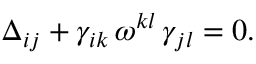Convert formula to latex. <formula><loc_0><loc_0><loc_500><loc_500>\Delta _ { i j } + \gamma _ { i k } \, \omega ^ { k l } \, \gamma _ { j l } = 0 .</formula> 